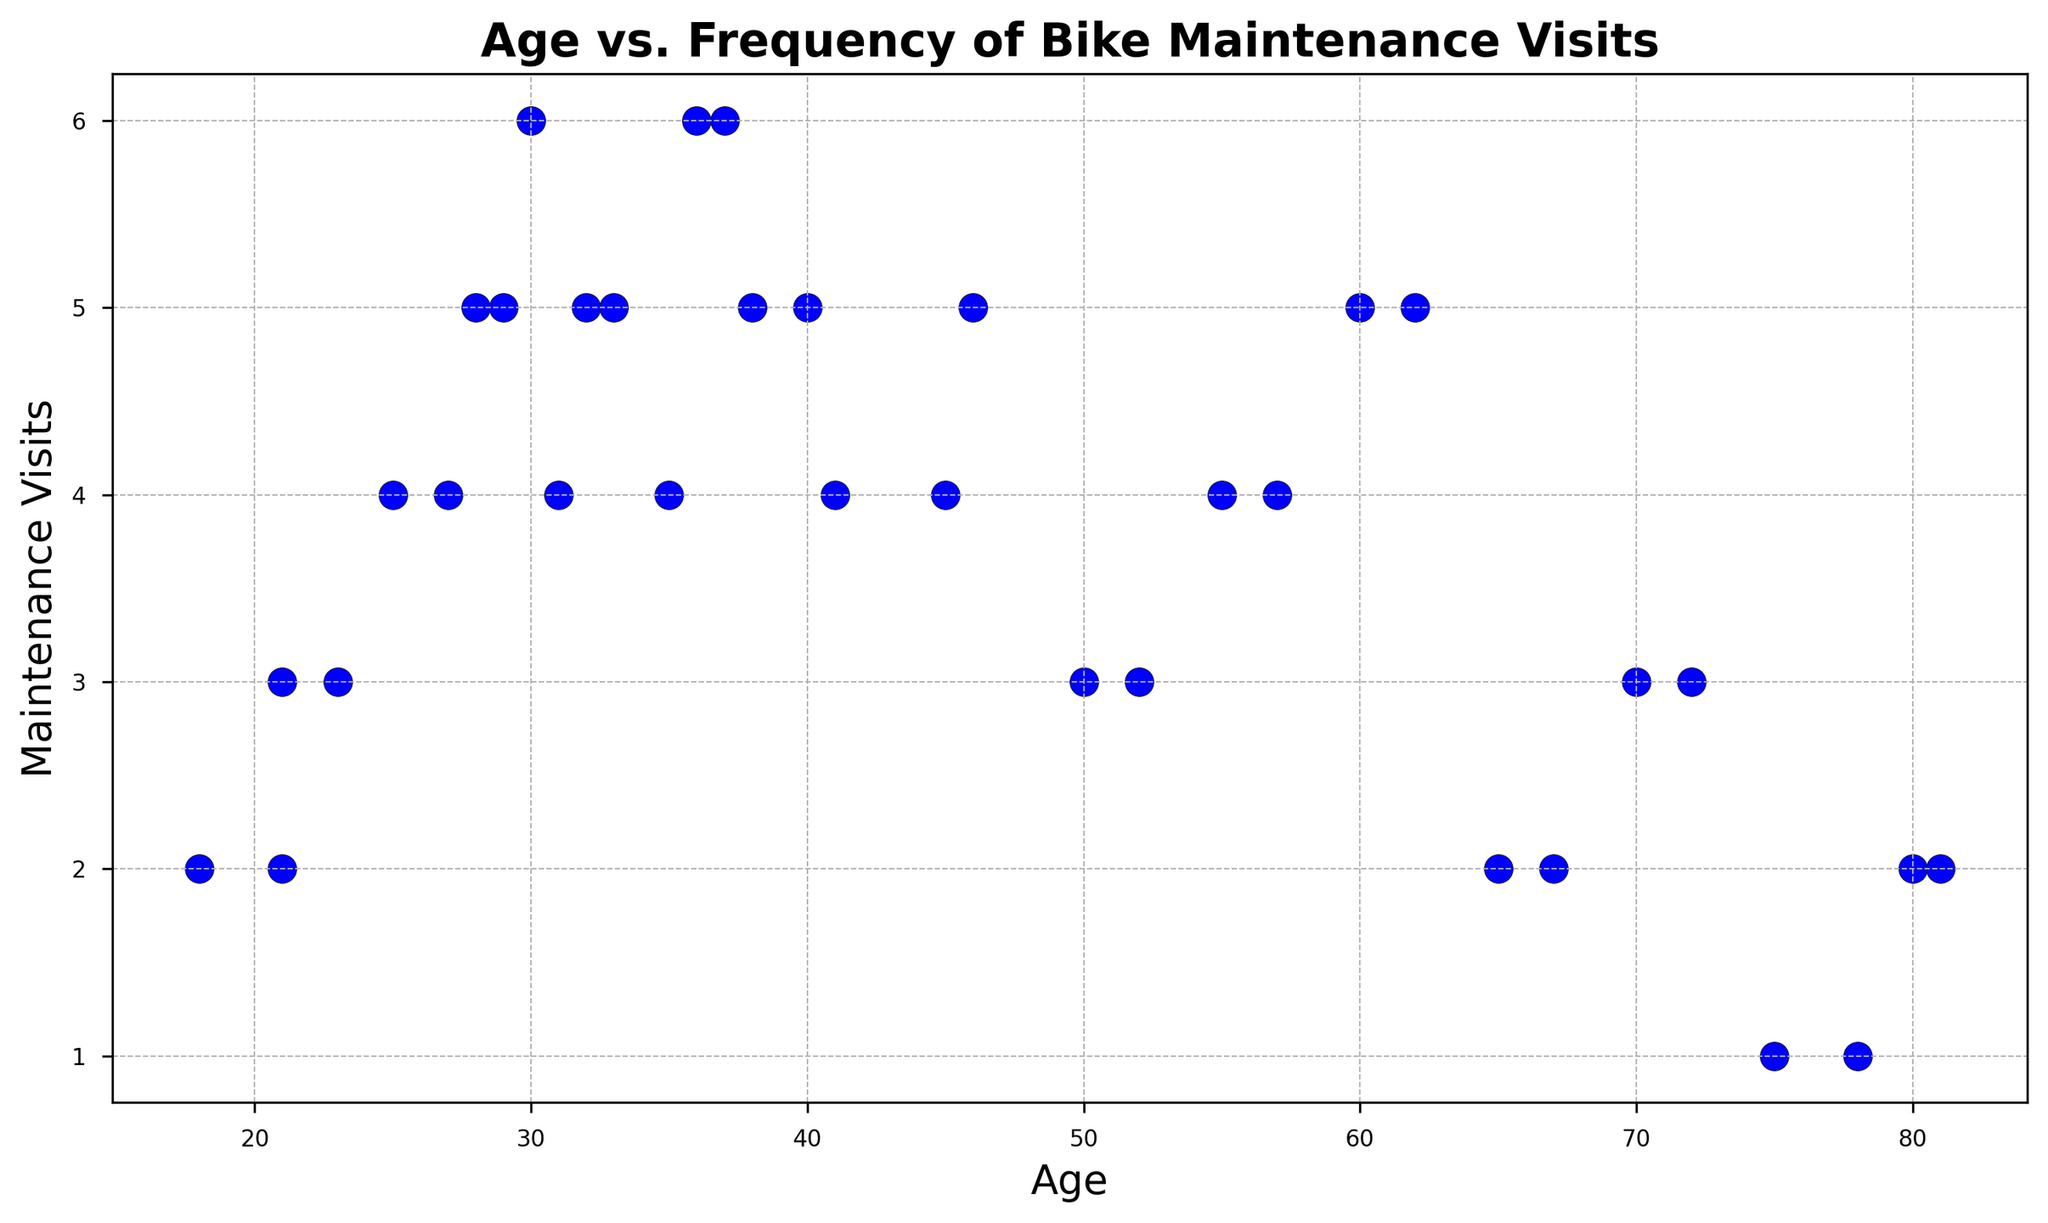What is the general trend between age and frequency of bike maintenance visits? To identify the trend, visually inspect how the points are distributed on the plot. Younger cyclists tend to have fewer maintenance visits, while middle-aged cyclists have relatively more frequent maintenance visits. The trend slightly decreases again for older cyclists.
Answer: The frequency of maintenance visits increases with age until middle age, then slightly decreases Do younger cyclists have fewer maintenance visits compared to middle-aged cyclists? Compare the number of maintenance visits for younger cyclists (ages 18-25) and middle-aged cyclists (ages 30-40). Younger cyclists tend to have fewer maintenance visits, generally around 2-4 visits, whereas middle-aged cyclists have 4-6 visits.
Answer: Yes Which age group has the highest frequency of bike maintenance visits? Look at the scatter plot and identify the age group corresponding to the highest value on the y-axis (maintenance visits). The highest visits (6 visits) are seen among cyclists in their 30s and 40s.
Answer: Cyclists aged 30-40 Is there an outlier in the number of maintenance visits among older cyclists? Inspect the scatter plot for points that differ significantly from the general pattern for older cyclists (ages 65-80). There's a noticeable point at age 75 with only 1 visit, which is an outlier considering the general pattern of 2-5 visits in older cyclists.
Answer: Yes How does the frequency of maintenance visits for cyclists aged 25 compare to those aged 50? Refer to the plot and compare the y-axis values for ages 25 and 50. Cyclists aged 25 have around 4 visits, while those aged 50 have around 3 visits.
Answer: Higher for cyclists aged 25 Among cyclists aged 21, 30, 45, and 70, who has the lowest frequency of maintenance visits? Locate the points for ages 21, 30, 45, and 70 on the scatter plot and compare the y-axis values. Cyclists aged 70 have the lowest frequency with 3 visits.
Answer: Cyclists aged 70 What is the average number of maintenance visits for cyclists aged 60 and above? Select the points for ages 60, 65, 70, 75, and 80 and calculate the average: (60: 5 visits, 65: 2 visits, 70: 3 visits, 75: 1 visit, 80: 2 visits). Average = (5 + 2 + 3 + 1 + 2) / 5 = 13 / 5 = 2.6 visits.
Answer: 2.6 visits Which age group shows the largest variation in the frequency of maintenance visits? Compare the range of maintenance visits across different age groups. The age group 30-40 shows the largest variation (from 3 to 6 visits).
Answer: Age group 30-40 Do cyclists in their 20s or 70s have a more consistent frequency of maintenance visits? Check the variation in maintenance visits for age groups in their 20s and 70s. The 20s group shows visits ranging from 2 to 5, while the 70s group ranges from 1 to 3. The 70s group has less variation.
Answer: Cyclists in their 70s How many maintenance visits do cyclists aged 32 and 38 have combined? Find the number of visits for ages 32 and 38 and sum them up. Age 32 = 5 visits, age 38 = 5 visits, so combined = 5 + 5 = 10 visits.
Answer: 10 visits 